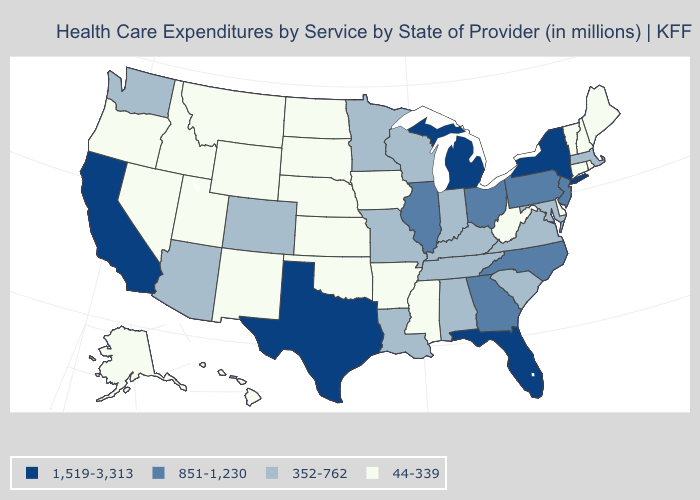Does New Hampshire have a higher value than Iowa?
Give a very brief answer. No. What is the value of Minnesota?
Concise answer only. 352-762. Which states have the lowest value in the USA?
Quick response, please. Alaska, Arkansas, Connecticut, Delaware, Hawaii, Idaho, Iowa, Kansas, Maine, Mississippi, Montana, Nebraska, Nevada, New Hampshire, New Mexico, North Dakota, Oklahoma, Oregon, Rhode Island, South Dakota, Utah, Vermont, West Virginia, Wyoming. What is the value of South Dakota?
Concise answer only. 44-339. Does Tennessee have the lowest value in the USA?
Answer briefly. No. Which states have the lowest value in the MidWest?
Short answer required. Iowa, Kansas, Nebraska, North Dakota, South Dakota. Which states have the highest value in the USA?
Short answer required. California, Florida, Michigan, New York, Texas. Name the states that have a value in the range 44-339?
Be succinct. Alaska, Arkansas, Connecticut, Delaware, Hawaii, Idaho, Iowa, Kansas, Maine, Mississippi, Montana, Nebraska, Nevada, New Hampshire, New Mexico, North Dakota, Oklahoma, Oregon, Rhode Island, South Dakota, Utah, Vermont, West Virginia, Wyoming. What is the value of Washington?
Write a very short answer. 352-762. Name the states that have a value in the range 44-339?
Be succinct. Alaska, Arkansas, Connecticut, Delaware, Hawaii, Idaho, Iowa, Kansas, Maine, Mississippi, Montana, Nebraska, Nevada, New Hampshire, New Mexico, North Dakota, Oklahoma, Oregon, Rhode Island, South Dakota, Utah, Vermont, West Virginia, Wyoming. Does the map have missing data?
Quick response, please. No. Name the states that have a value in the range 1,519-3,313?
Give a very brief answer. California, Florida, Michigan, New York, Texas. Does North Carolina have a higher value than New York?
Short answer required. No. What is the highest value in the USA?
Keep it brief. 1,519-3,313. Among the states that border Georgia , does Florida have the highest value?
Concise answer only. Yes. 